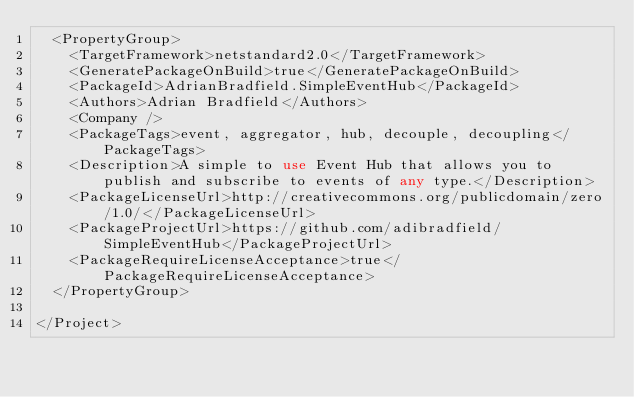<code> <loc_0><loc_0><loc_500><loc_500><_XML_>  <PropertyGroup>
    <TargetFramework>netstandard2.0</TargetFramework>
    <GeneratePackageOnBuild>true</GeneratePackageOnBuild>
    <PackageId>AdrianBradfield.SimpleEventHub</PackageId>
    <Authors>Adrian Bradfield</Authors>
    <Company />
    <PackageTags>event, aggregator, hub, decouple, decoupling</PackageTags>
    <Description>A simple to use Event Hub that allows you to publish and subscribe to events of any type.</Description>
    <PackageLicenseUrl>http://creativecommons.org/publicdomain/zero/1.0/</PackageLicenseUrl>
    <PackageProjectUrl>https://github.com/adibradfield/SimpleEventHub</PackageProjectUrl>
    <PackageRequireLicenseAcceptance>true</PackageRequireLicenseAcceptance>
  </PropertyGroup>

</Project>
</code> 